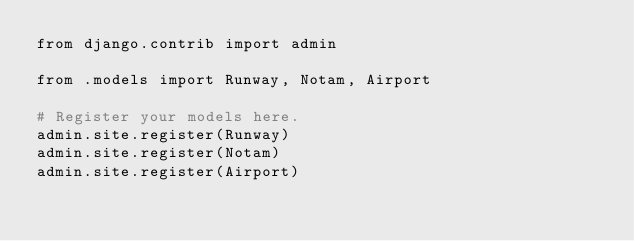<code> <loc_0><loc_0><loc_500><loc_500><_Python_>from django.contrib import admin

from .models import Runway, Notam, Airport

# Register your models here.
admin.site.register(Runway)
admin.site.register(Notam)
admin.site.register(Airport)</code> 